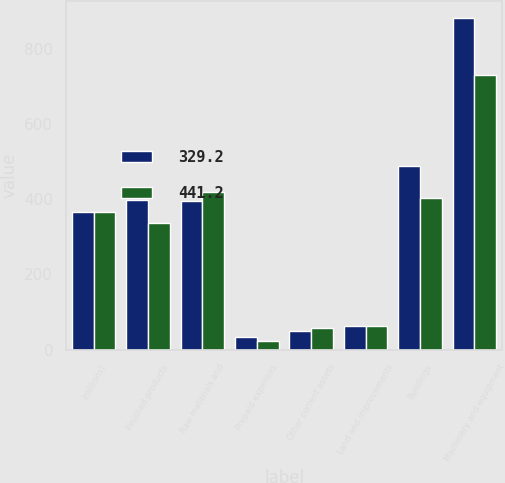Convert chart to OTSL. <chart><loc_0><loc_0><loc_500><loc_500><stacked_bar_chart><ecel><fcel>(millions)<fcel>Finished products<fcel>Raw materials and<fcel>Prepaid expenses<fcel>Other current assets<fcel>Land and improvements<fcel>Buildings<fcel>Machinery and equipment<nl><fcel>329.2<fcel>365.75<fcel>398.1<fcel>395.2<fcel>32.4<fcel>49.4<fcel>63.2<fcel>488.3<fcel>882<nl><fcel>441.2<fcel>365.75<fcel>336.3<fcel>420<fcel>23.6<fcel>58.3<fcel>62.4<fcel>402.9<fcel>730.1<nl></chart> 